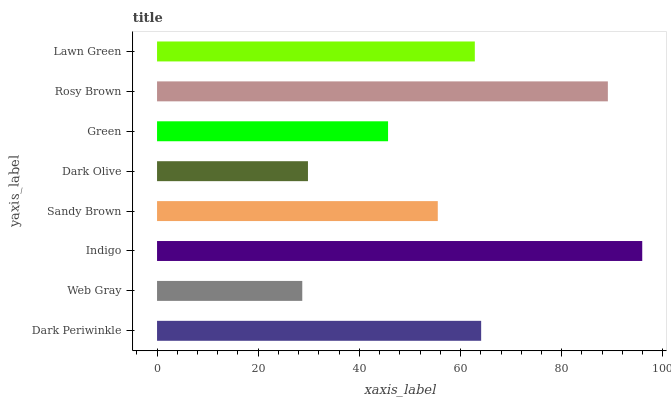Is Web Gray the minimum?
Answer yes or no. Yes. Is Indigo the maximum?
Answer yes or no. Yes. Is Indigo the minimum?
Answer yes or no. No. Is Web Gray the maximum?
Answer yes or no. No. Is Indigo greater than Web Gray?
Answer yes or no. Yes. Is Web Gray less than Indigo?
Answer yes or no. Yes. Is Web Gray greater than Indigo?
Answer yes or no. No. Is Indigo less than Web Gray?
Answer yes or no. No. Is Lawn Green the high median?
Answer yes or no. Yes. Is Sandy Brown the low median?
Answer yes or no. Yes. Is Web Gray the high median?
Answer yes or no. No. Is Rosy Brown the low median?
Answer yes or no. No. 